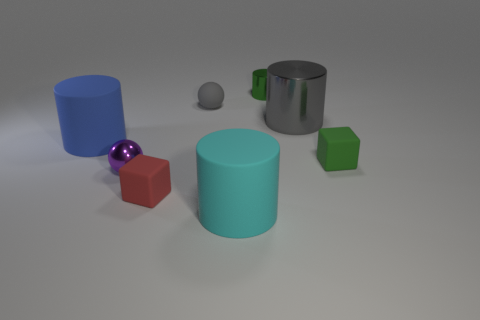There is a large cylinder that is the same color as the rubber ball; what material is it?
Your answer should be very brief. Metal. Does the small matte ball have the same color as the cylinder right of the green metal object?
Ensure brevity in your answer.  Yes. There is a purple ball that is the same size as the green block; what is its material?
Provide a short and direct response. Metal. How big is the gray thing to the right of the gray matte object?
Offer a terse response. Large. What is the gray cylinder made of?
Your answer should be compact. Metal. What number of things are either large matte objects in front of the tiny purple sphere or matte things on the left side of the green metallic object?
Your answer should be very brief. 4. How many other objects are the same color as the small cylinder?
Make the answer very short. 1. Does the purple metal thing have the same shape as the small gray rubber thing that is to the right of the big blue cylinder?
Your answer should be compact. Yes. Is the number of small purple objects on the left side of the tiny gray sphere less than the number of small objects that are to the left of the green rubber block?
Provide a succinct answer. Yes. There is a large cyan object that is the same shape as the big blue rubber object; what is its material?
Your response must be concise. Rubber. 